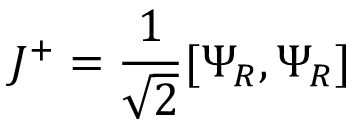<formula> <loc_0><loc_0><loc_500><loc_500>J ^ { + } = { \frac { 1 } { \sqrt { 2 } } } [ \Psi _ { R } , \Psi _ { R } ]</formula> 